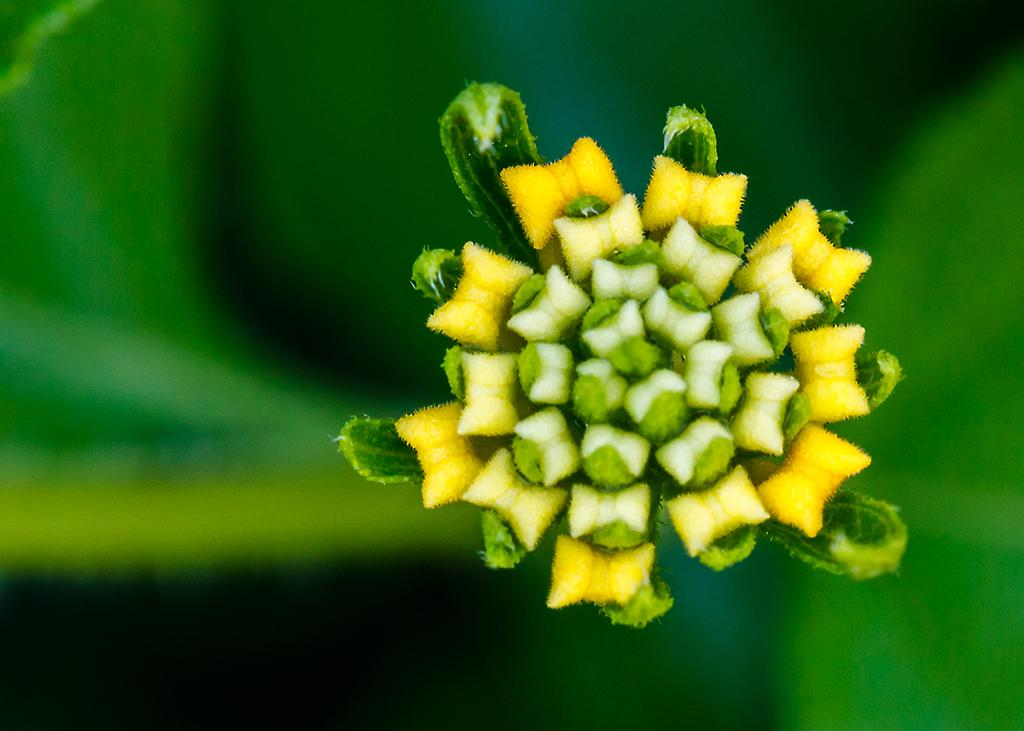What is the main subject of the image? There is a flower in the middle of the image. What color is the background of the image? The background of the image is green. What type of fuel is being used by the flower in the image? There is no fuel present in the image, as it features a flower and a green background. 